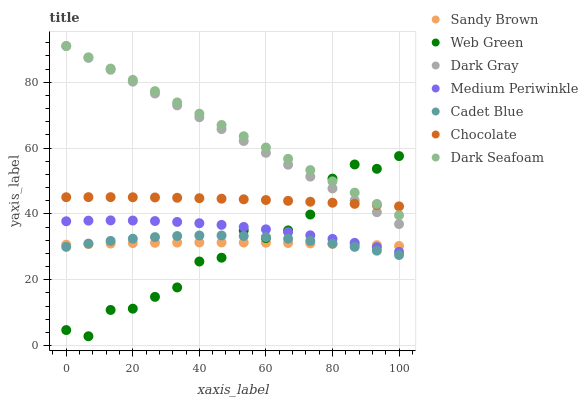Does Web Green have the minimum area under the curve?
Answer yes or no. Yes. Does Dark Seafoam have the maximum area under the curve?
Answer yes or no. Yes. Does Medium Periwinkle have the minimum area under the curve?
Answer yes or no. No. Does Medium Periwinkle have the maximum area under the curve?
Answer yes or no. No. Is Dark Gray the smoothest?
Answer yes or no. Yes. Is Web Green the roughest?
Answer yes or no. Yes. Is Medium Periwinkle the smoothest?
Answer yes or no. No. Is Medium Periwinkle the roughest?
Answer yes or no. No. Does Web Green have the lowest value?
Answer yes or no. Yes. Does Medium Periwinkle have the lowest value?
Answer yes or no. No. Does Dark Seafoam have the highest value?
Answer yes or no. Yes. Does Medium Periwinkle have the highest value?
Answer yes or no. No. Is Sandy Brown less than Dark Seafoam?
Answer yes or no. Yes. Is Dark Seafoam greater than Sandy Brown?
Answer yes or no. Yes. Does Medium Periwinkle intersect Sandy Brown?
Answer yes or no. Yes. Is Medium Periwinkle less than Sandy Brown?
Answer yes or no. No. Is Medium Periwinkle greater than Sandy Brown?
Answer yes or no. No. Does Sandy Brown intersect Dark Seafoam?
Answer yes or no. No. 